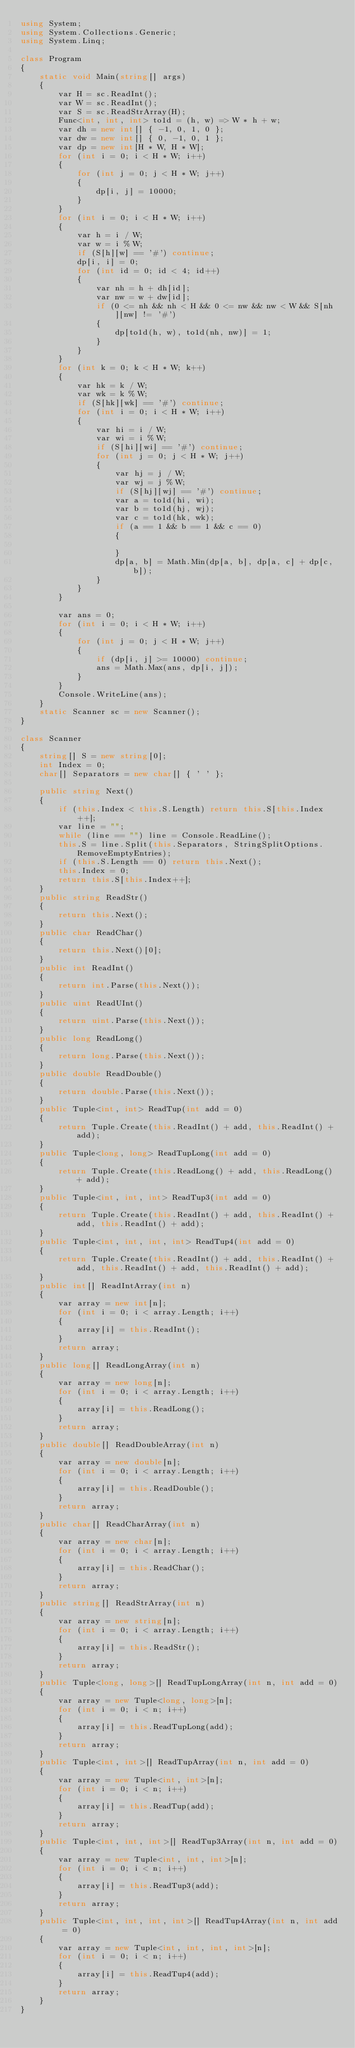Convert code to text. <code><loc_0><loc_0><loc_500><loc_500><_C#_>using System;
using System.Collections.Generic;
using System.Linq;

class Program
{
    static void Main(string[] args)
    {
        var H = sc.ReadInt();
        var W = sc.ReadInt();
        var S = sc.ReadStrArray(H);
        Func<int, int, int> to1d = (h, w) => W * h + w;
        var dh = new int[] { -1, 0, 1, 0 };
        var dw = new int[] { 0, -1, 0, 1 };
        var dp = new int[H * W, H * W];
        for (int i = 0; i < H * W; i++)
        {
            for (int j = 0; j < H * W; j++)
            {
                dp[i, j] = 10000;
            }
        }
        for (int i = 0; i < H * W; i++)
        {
            var h = i / W;
            var w = i % W;
            if (S[h][w] == '#') continue;
            dp[i, i] = 0;
            for (int id = 0; id < 4; id++)
            {
                var nh = h + dh[id];
                var nw = w + dw[id];
                if (0 <= nh && nh < H && 0 <= nw && nw < W && S[nh][nw] != '#')
                {
                    dp[to1d(h, w), to1d(nh, nw)] = 1;
                }
            }
        }
        for (int k = 0; k < H * W; k++)
        {
            var hk = k / W;
            var wk = k % W;
            if (S[hk][wk] == '#') continue;
            for (int i = 0; i < H * W; i++)
            {
                var hi = i / W;
                var wi = i % W;
                if (S[hi][wi] == '#') continue;
                for (int j = 0; j < H * W; j++)
                {
                    var hj = j / W;
                    var wj = j % W;
                    if (S[hj][wj] == '#') continue;
                    var a = to1d(hi, wi);
                    var b = to1d(hj, wj);
                    var c = to1d(hk, wk);
                    if (a == 1 && b == 1 && c == 0)
                    {

                    }
                    dp[a, b] = Math.Min(dp[a, b], dp[a, c] + dp[c, b]);
                }
            }
        }

        var ans = 0;
        for (int i = 0; i < H * W; i++)
        {
            for (int j = 0; j < H * W; j++)
            {
                if (dp[i, j] >= 10000) continue;
                ans = Math.Max(ans, dp[i, j]);
            }
        }
        Console.WriteLine(ans);
    }
    static Scanner sc = new Scanner();
}

class Scanner
{
    string[] S = new string[0];
    int Index = 0;
    char[] Separators = new char[] { ' ' };

    public string Next()
    {
        if (this.Index < this.S.Length) return this.S[this.Index++];
        var line = "";
        while (line == "") line = Console.ReadLine();
        this.S = line.Split(this.Separators, StringSplitOptions.RemoveEmptyEntries);
        if (this.S.Length == 0) return this.Next();
        this.Index = 0;
        return this.S[this.Index++];
    }
    public string ReadStr()
    {
        return this.Next();
    }
    public char ReadChar()
    {
        return this.Next()[0];
    }
    public int ReadInt()
    {
        return int.Parse(this.Next());
    }
    public uint ReadUInt()
    {
        return uint.Parse(this.Next());
    }
    public long ReadLong()
    {
        return long.Parse(this.Next());
    }
    public double ReadDouble()
    {
        return double.Parse(this.Next());
    }
    public Tuple<int, int> ReadTup(int add = 0)
    {
        return Tuple.Create(this.ReadInt() + add, this.ReadInt() + add);
    }
    public Tuple<long, long> ReadTupLong(int add = 0)
    {
        return Tuple.Create(this.ReadLong() + add, this.ReadLong() + add);
    }
    public Tuple<int, int, int> ReadTup3(int add = 0)
    {
        return Tuple.Create(this.ReadInt() + add, this.ReadInt() + add, this.ReadInt() + add);
    }
    public Tuple<int, int, int, int> ReadTup4(int add = 0)
    {
        return Tuple.Create(this.ReadInt() + add, this.ReadInt() + add, this.ReadInt() + add, this.ReadInt() + add);
    }
    public int[] ReadIntArray(int n)
    {
        var array = new int[n];
        for (int i = 0; i < array.Length; i++)
        {
            array[i] = this.ReadInt();
        }
        return array;
    }
    public long[] ReadLongArray(int n)
    {
        var array = new long[n];
        for (int i = 0; i < array.Length; i++)
        {
            array[i] = this.ReadLong();
        }
        return array;
    }
    public double[] ReadDoubleArray(int n)
    {
        var array = new double[n];
        for (int i = 0; i < array.Length; i++)
        {
            array[i] = this.ReadDouble();
        }
        return array;
    }
    public char[] ReadCharArray(int n)
    {
        var array = new char[n];
        for (int i = 0; i < array.Length; i++)
        {
            array[i] = this.ReadChar();
        }
        return array;
    }
    public string[] ReadStrArray(int n)
    {
        var array = new string[n];
        for (int i = 0; i < array.Length; i++)
        {
            array[i] = this.ReadStr();
        }
        return array;
    }
    public Tuple<long, long>[] ReadTupLongArray(int n, int add = 0)
    {
        var array = new Tuple<long, long>[n];
        for (int i = 0; i < n; i++)
        {
            array[i] = this.ReadTupLong(add);
        }
        return array;
    }
    public Tuple<int, int>[] ReadTupArray(int n, int add = 0)
    {
        var array = new Tuple<int, int>[n];
        for (int i = 0; i < n; i++)
        {
            array[i] = this.ReadTup(add);
        }
        return array;
    }
    public Tuple<int, int, int>[] ReadTup3Array(int n, int add = 0)
    {
        var array = new Tuple<int, int, int>[n];
        for (int i = 0; i < n; i++)
        {
            array[i] = this.ReadTup3(add);
        }
        return array;
    }
    public Tuple<int, int, int, int>[] ReadTup4Array(int n, int add = 0)
    {
        var array = new Tuple<int, int, int, int>[n];
        for (int i = 0; i < n; i++)
        {
            array[i] = this.ReadTup4(add);
        }
        return array;
    }
}
</code> 